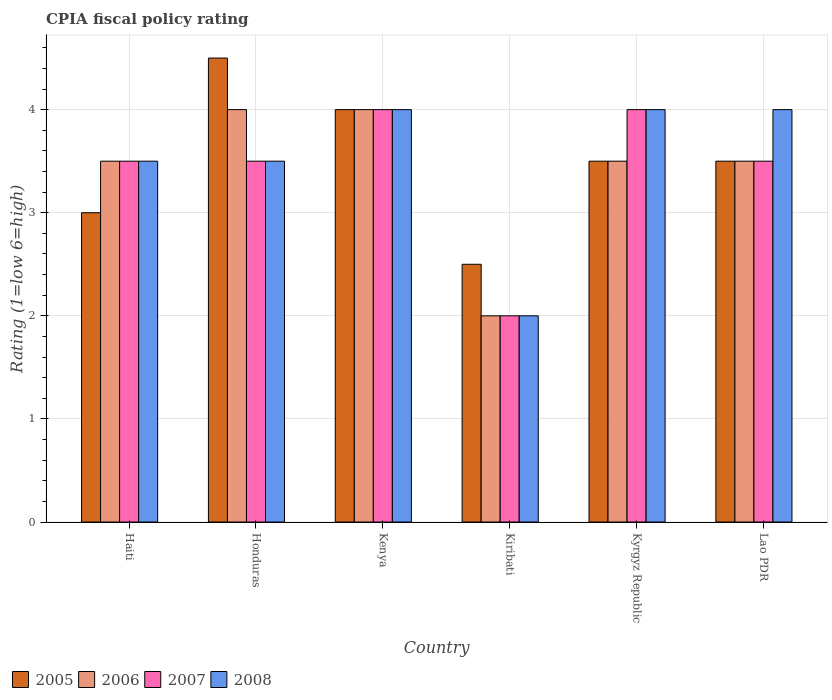Are the number of bars per tick equal to the number of legend labels?
Your answer should be very brief. Yes. How many bars are there on the 4th tick from the right?
Your answer should be very brief. 4. What is the label of the 3rd group of bars from the left?
Keep it short and to the point. Kenya. Across all countries, what is the maximum CPIA rating in 2005?
Make the answer very short. 4.5. In which country was the CPIA rating in 2007 maximum?
Give a very brief answer. Kenya. In which country was the CPIA rating in 2008 minimum?
Provide a short and direct response. Kiribati. What is the total CPIA rating in 2006 in the graph?
Give a very brief answer. 20.5. What is the ratio of the CPIA rating in 2006 in Kyrgyz Republic to that in Lao PDR?
Give a very brief answer. 1. Is the CPIA rating in 2006 in Haiti less than that in Kiribati?
Give a very brief answer. No. What is the difference between the highest and the second highest CPIA rating in 2005?
Ensure brevity in your answer.  -1. What is the difference between the highest and the lowest CPIA rating in 2008?
Give a very brief answer. 2. Is the sum of the CPIA rating in 2007 in Haiti and Kiribati greater than the maximum CPIA rating in 2008 across all countries?
Your answer should be very brief. Yes. Is it the case that in every country, the sum of the CPIA rating in 2007 and CPIA rating in 2005 is greater than the sum of CPIA rating in 2008 and CPIA rating in 2006?
Offer a terse response. No. Are all the bars in the graph horizontal?
Your response must be concise. No. How many countries are there in the graph?
Provide a succinct answer. 6. Does the graph contain any zero values?
Provide a short and direct response. No. What is the title of the graph?
Offer a very short reply. CPIA fiscal policy rating. Does "1978" appear as one of the legend labels in the graph?
Your answer should be very brief. No. What is the label or title of the X-axis?
Your answer should be very brief. Country. What is the label or title of the Y-axis?
Your answer should be compact. Rating (1=low 6=high). What is the Rating (1=low 6=high) in 2005 in Haiti?
Offer a terse response. 3. What is the Rating (1=low 6=high) in 2007 in Haiti?
Make the answer very short. 3.5. What is the Rating (1=low 6=high) of 2008 in Honduras?
Your answer should be very brief. 3.5. What is the Rating (1=low 6=high) in 2007 in Kenya?
Ensure brevity in your answer.  4. What is the Rating (1=low 6=high) of 2008 in Kenya?
Give a very brief answer. 4. What is the Rating (1=low 6=high) of 2005 in Kiribati?
Offer a very short reply. 2.5. What is the Rating (1=low 6=high) of 2006 in Kiribati?
Your response must be concise. 2. What is the Rating (1=low 6=high) in 2008 in Kiribati?
Give a very brief answer. 2. What is the Rating (1=low 6=high) of 2005 in Kyrgyz Republic?
Offer a terse response. 3.5. What is the Rating (1=low 6=high) in 2006 in Kyrgyz Republic?
Your answer should be very brief. 3.5. What is the Rating (1=low 6=high) in 2008 in Kyrgyz Republic?
Your answer should be compact. 4. What is the Rating (1=low 6=high) of 2005 in Lao PDR?
Your answer should be compact. 3.5. What is the Rating (1=low 6=high) of 2006 in Lao PDR?
Offer a terse response. 3.5. What is the Rating (1=low 6=high) of 2007 in Lao PDR?
Provide a succinct answer. 3.5. Across all countries, what is the maximum Rating (1=low 6=high) of 2005?
Your answer should be compact. 4.5. Across all countries, what is the maximum Rating (1=low 6=high) of 2008?
Your answer should be very brief. 4. Across all countries, what is the minimum Rating (1=low 6=high) in 2006?
Your answer should be compact. 2. Across all countries, what is the minimum Rating (1=low 6=high) of 2007?
Your answer should be very brief. 2. Across all countries, what is the minimum Rating (1=low 6=high) in 2008?
Keep it short and to the point. 2. What is the total Rating (1=low 6=high) of 2007 in the graph?
Your answer should be compact. 20.5. What is the total Rating (1=low 6=high) in 2008 in the graph?
Make the answer very short. 21. What is the difference between the Rating (1=low 6=high) of 2006 in Haiti and that in Honduras?
Your answer should be compact. -0.5. What is the difference between the Rating (1=low 6=high) of 2008 in Haiti and that in Kenya?
Ensure brevity in your answer.  -0.5. What is the difference between the Rating (1=low 6=high) of 2005 in Haiti and that in Kiribati?
Make the answer very short. 0.5. What is the difference between the Rating (1=low 6=high) in 2007 in Haiti and that in Kiribati?
Give a very brief answer. 1.5. What is the difference between the Rating (1=low 6=high) of 2007 in Haiti and that in Kyrgyz Republic?
Give a very brief answer. -0.5. What is the difference between the Rating (1=low 6=high) in 2008 in Haiti and that in Lao PDR?
Provide a succinct answer. -0.5. What is the difference between the Rating (1=low 6=high) in 2005 in Honduras and that in Kenya?
Ensure brevity in your answer.  0.5. What is the difference between the Rating (1=low 6=high) of 2006 in Honduras and that in Kenya?
Give a very brief answer. 0. What is the difference between the Rating (1=low 6=high) of 2007 in Honduras and that in Kiribati?
Ensure brevity in your answer.  1.5. What is the difference between the Rating (1=low 6=high) in 2008 in Honduras and that in Kiribati?
Offer a very short reply. 1.5. What is the difference between the Rating (1=low 6=high) in 2005 in Honduras and that in Kyrgyz Republic?
Provide a short and direct response. 1. What is the difference between the Rating (1=low 6=high) of 2007 in Honduras and that in Kyrgyz Republic?
Offer a terse response. -0.5. What is the difference between the Rating (1=low 6=high) in 2008 in Honduras and that in Lao PDR?
Provide a succinct answer. -0.5. What is the difference between the Rating (1=low 6=high) in 2005 in Kenya and that in Kyrgyz Republic?
Ensure brevity in your answer.  0.5. What is the difference between the Rating (1=low 6=high) of 2006 in Kenya and that in Kyrgyz Republic?
Your response must be concise. 0.5. What is the difference between the Rating (1=low 6=high) of 2006 in Kenya and that in Lao PDR?
Provide a succinct answer. 0.5. What is the difference between the Rating (1=low 6=high) in 2007 in Kenya and that in Lao PDR?
Ensure brevity in your answer.  0.5. What is the difference between the Rating (1=low 6=high) of 2008 in Kenya and that in Lao PDR?
Your answer should be compact. 0. What is the difference between the Rating (1=low 6=high) in 2006 in Kiribati and that in Kyrgyz Republic?
Offer a very short reply. -1.5. What is the difference between the Rating (1=low 6=high) in 2006 in Kiribati and that in Lao PDR?
Provide a succinct answer. -1.5. What is the difference between the Rating (1=low 6=high) in 2008 in Kiribati and that in Lao PDR?
Ensure brevity in your answer.  -2. What is the difference between the Rating (1=low 6=high) of 2005 in Kyrgyz Republic and that in Lao PDR?
Offer a very short reply. 0. What is the difference between the Rating (1=low 6=high) of 2006 in Kyrgyz Republic and that in Lao PDR?
Provide a short and direct response. 0. What is the difference between the Rating (1=low 6=high) in 2005 in Haiti and the Rating (1=low 6=high) in 2008 in Honduras?
Ensure brevity in your answer.  -0.5. What is the difference between the Rating (1=low 6=high) of 2005 in Haiti and the Rating (1=low 6=high) of 2007 in Kenya?
Keep it short and to the point. -1. What is the difference between the Rating (1=low 6=high) of 2006 in Haiti and the Rating (1=low 6=high) of 2008 in Kenya?
Provide a short and direct response. -0.5. What is the difference between the Rating (1=low 6=high) of 2007 in Haiti and the Rating (1=low 6=high) of 2008 in Kiribati?
Provide a short and direct response. 1.5. What is the difference between the Rating (1=low 6=high) of 2005 in Haiti and the Rating (1=low 6=high) of 2006 in Kyrgyz Republic?
Your answer should be very brief. -0.5. What is the difference between the Rating (1=low 6=high) of 2005 in Haiti and the Rating (1=low 6=high) of 2007 in Kyrgyz Republic?
Provide a short and direct response. -1. What is the difference between the Rating (1=low 6=high) in 2006 in Haiti and the Rating (1=low 6=high) in 2007 in Kyrgyz Republic?
Make the answer very short. -0.5. What is the difference between the Rating (1=low 6=high) of 2007 in Haiti and the Rating (1=low 6=high) of 2008 in Kyrgyz Republic?
Provide a short and direct response. -0.5. What is the difference between the Rating (1=low 6=high) of 2005 in Haiti and the Rating (1=low 6=high) of 2007 in Lao PDR?
Keep it short and to the point. -0.5. What is the difference between the Rating (1=low 6=high) of 2005 in Haiti and the Rating (1=low 6=high) of 2008 in Lao PDR?
Provide a short and direct response. -1. What is the difference between the Rating (1=low 6=high) in 2005 in Honduras and the Rating (1=low 6=high) in 2006 in Kenya?
Provide a short and direct response. 0.5. What is the difference between the Rating (1=low 6=high) of 2005 in Honduras and the Rating (1=low 6=high) of 2007 in Kenya?
Provide a succinct answer. 0.5. What is the difference between the Rating (1=low 6=high) in 2005 in Honduras and the Rating (1=low 6=high) in 2008 in Kenya?
Your response must be concise. 0.5. What is the difference between the Rating (1=low 6=high) of 2007 in Honduras and the Rating (1=low 6=high) of 2008 in Kenya?
Provide a succinct answer. -0.5. What is the difference between the Rating (1=low 6=high) of 2005 in Honduras and the Rating (1=low 6=high) of 2006 in Kiribati?
Your answer should be compact. 2.5. What is the difference between the Rating (1=low 6=high) in 2005 in Honduras and the Rating (1=low 6=high) in 2007 in Kiribati?
Offer a terse response. 2.5. What is the difference between the Rating (1=low 6=high) of 2005 in Honduras and the Rating (1=low 6=high) of 2008 in Kiribati?
Provide a short and direct response. 2.5. What is the difference between the Rating (1=low 6=high) of 2006 in Honduras and the Rating (1=low 6=high) of 2007 in Kiribati?
Your response must be concise. 2. What is the difference between the Rating (1=low 6=high) of 2007 in Honduras and the Rating (1=low 6=high) of 2008 in Kiribati?
Provide a succinct answer. 1.5. What is the difference between the Rating (1=low 6=high) in 2005 in Honduras and the Rating (1=low 6=high) in 2006 in Kyrgyz Republic?
Provide a succinct answer. 1. What is the difference between the Rating (1=low 6=high) of 2005 in Honduras and the Rating (1=low 6=high) of 2007 in Kyrgyz Republic?
Your response must be concise. 0.5. What is the difference between the Rating (1=low 6=high) of 2006 in Honduras and the Rating (1=low 6=high) of 2007 in Kyrgyz Republic?
Give a very brief answer. 0. What is the difference between the Rating (1=low 6=high) of 2005 in Honduras and the Rating (1=low 6=high) of 2008 in Lao PDR?
Provide a succinct answer. 0.5. What is the difference between the Rating (1=low 6=high) of 2007 in Honduras and the Rating (1=low 6=high) of 2008 in Lao PDR?
Keep it short and to the point. -0.5. What is the difference between the Rating (1=low 6=high) in 2005 in Kenya and the Rating (1=low 6=high) in 2007 in Kiribati?
Keep it short and to the point. 2. What is the difference between the Rating (1=low 6=high) in 2005 in Kenya and the Rating (1=low 6=high) in 2006 in Kyrgyz Republic?
Ensure brevity in your answer.  0.5. What is the difference between the Rating (1=low 6=high) of 2005 in Kenya and the Rating (1=low 6=high) of 2008 in Kyrgyz Republic?
Offer a terse response. 0. What is the difference between the Rating (1=low 6=high) in 2006 in Kenya and the Rating (1=low 6=high) in 2007 in Kyrgyz Republic?
Make the answer very short. 0. What is the difference between the Rating (1=low 6=high) of 2006 in Kenya and the Rating (1=low 6=high) of 2008 in Kyrgyz Republic?
Give a very brief answer. 0. What is the difference between the Rating (1=low 6=high) in 2005 in Kenya and the Rating (1=low 6=high) in 2006 in Lao PDR?
Ensure brevity in your answer.  0.5. What is the difference between the Rating (1=low 6=high) of 2006 in Kenya and the Rating (1=low 6=high) of 2008 in Lao PDR?
Your answer should be compact. 0. What is the difference between the Rating (1=low 6=high) of 2005 in Kiribati and the Rating (1=low 6=high) of 2006 in Kyrgyz Republic?
Your answer should be compact. -1. What is the difference between the Rating (1=low 6=high) of 2005 in Kiribati and the Rating (1=low 6=high) of 2008 in Kyrgyz Republic?
Offer a terse response. -1.5. What is the difference between the Rating (1=low 6=high) in 2006 in Kiribati and the Rating (1=low 6=high) in 2007 in Kyrgyz Republic?
Make the answer very short. -2. What is the difference between the Rating (1=low 6=high) of 2006 in Kiribati and the Rating (1=low 6=high) of 2008 in Kyrgyz Republic?
Ensure brevity in your answer.  -2. What is the difference between the Rating (1=low 6=high) of 2007 in Kiribati and the Rating (1=low 6=high) of 2008 in Kyrgyz Republic?
Your answer should be very brief. -2. What is the difference between the Rating (1=low 6=high) of 2005 in Kiribati and the Rating (1=low 6=high) of 2007 in Lao PDR?
Provide a short and direct response. -1. What is the difference between the Rating (1=low 6=high) in 2006 in Kiribati and the Rating (1=low 6=high) in 2007 in Lao PDR?
Make the answer very short. -1.5. What is the difference between the Rating (1=low 6=high) of 2006 in Kiribati and the Rating (1=low 6=high) of 2008 in Lao PDR?
Keep it short and to the point. -2. What is the difference between the Rating (1=low 6=high) in 2007 in Kiribati and the Rating (1=low 6=high) in 2008 in Lao PDR?
Give a very brief answer. -2. What is the average Rating (1=low 6=high) in 2005 per country?
Provide a succinct answer. 3.5. What is the average Rating (1=low 6=high) in 2006 per country?
Your answer should be compact. 3.42. What is the average Rating (1=low 6=high) of 2007 per country?
Give a very brief answer. 3.42. What is the difference between the Rating (1=low 6=high) in 2006 and Rating (1=low 6=high) in 2007 in Haiti?
Provide a short and direct response. 0. What is the difference between the Rating (1=low 6=high) in 2007 and Rating (1=low 6=high) in 2008 in Haiti?
Your answer should be very brief. 0. What is the difference between the Rating (1=low 6=high) of 2005 and Rating (1=low 6=high) of 2007 in Kenya?
Your answer should be compact. 0. What is the difference between the Rating (1=low 6=high) of 2005 and Rating (1=low 6=high) of 2008 in Kenya?
Offer a very short reply. 0. What is the difference between the Rating (1=low 6=high) of 2005 and Rating (1=low 6=high) of 2006 in Kiribati?
Your answer should be very brief. 0.5. What is the difference between the Rating (1=low 6=high) in 2005 and Rating (1=low 6=high) in 2007 in Kiribati?
Your answer should be very brief. 0.5. What is the difference between the Rating (1=low 6=high) in 2006 and Rating (1=low 6=high) in 2008 in Kiribati?
Ensure brevity in your answer.  0. What is the difference between the Rating (1=low 6=high) of 2007 and Rating (1=low 6=high) of 2008 in Kiribati?
Make the answer very short. 0. What is the difference between the Rating (1=low 6=high) in 2005 and Rating (1=low 6=high) in 2006 in Kyrgyz Republic?
Provide a short and direct response. 0. What is the difference between the Rating (1=low 6=high) of 2006 and Rating (1=low 6=high) of 2007 in Kyrgyz Republic?
Your response must be concise. -0.5. What is the difference between the Rating (1=low 6=high) of 2006 and Rating (1=low 6=high) of 2008 in Kyrgyz Republic?
Offer a terse response. -0.5. What is the difference between the Rating (1=low 6=high) of 2005 and Rating (1=low 6=high) of 2006 in Lao PDR?
Make the answer very short. 0. What is the difference between the Rating (1=low 6=high) in 2005 and Rating (1=low 6=high) in 2007 in Lao PDR?
Offer a very short reply. 0. What is the difference between the Rating (1=low 6=high) in 2005 and Rating (1=low 6=high) in 2008 in Lao PDR?
Provide a short and direct response. -0.5. What is the difference between the Rating (1=low 6=high) of 2006 and Rating (1=low 6=high) of 2008 in Lao PDR?
Your response must be concise. -0.5. What is the ratio of the Rating (1=low 6=high) in 2006 in Haiti to that in Honduras?
Keep it short and to the point. 0.88. What is the ratio of the Rating (1=low 6=high) in 2007 in Haiti to that in Honduras?
Your response must be concise. 1. What is the ratio of the Rating (1=low 6=high) of 2008 in Haiti to that in Honduras?
Offer a terse response. 1. What is the ratio of the Rating (1=low 6=high) of 2005 in Haiti to that in Kiribati?
Your response must be concise. 1.2. What is the ratio of the Rating (1=low 6=high) in 2008 in Haiti to that in Kiribati?
Your answer should be compact. 1.75. What is the ratio of the Rating (1=low 6=high) in 2006 in Haiti to that in Lao PDR?
Give a very brief answer. 1. What is the ratio of the Rating (1=low 6=high) in 2008 in Haiti to that in Lao PDR?
Your response must be concise. 0.88. What is the ratio of the Rating (1=low 6=high) of 2005 in Honduras to that in Kenya?
Provide a short and direct response. 1.12. What is the ratio of the Rating (1=low 6=high) in 2008 in Honduras to that in Kenya?
Make the answer very short. 0.88. What is the ratio of the Rating (1=low 6=high) of 2007 in Honduras to that in Kiribati?
Make the answer very short. 1.75. What is the ratio of the Rating (1=low 6=high) of 2007 in Honduras to that in Kyrgyz Republic?
Give a very brief answer. 0.88. What is the ratio of the Rating (1=low 6=high) in 2008 in Honduras to that in Lao PDR?
Keep it short and to the point. 0.88. What is the ratio of the Rating (1=low 6=high) of 2006 in Kenya to that in Kiribati?
Give a very brief answer. 2. What is the ratio of the Rating (1=low 6=high) of 2007 in Kenya to that in Kiribati?
Ensure brevity in your answer.  2. What is the ratio of the Rating (1=low 6=high) of 2008 in Kenya to that in Kiribati?
Offer a terse response. 2. What is the ratio of the Rating (1=low 6=high) in 2005 in Kenya to that in Kyrgyz Republic?
Make the answer very short. 1.14. What is the ratio of the Rating (1=low 6=high) of 2006 in Kenya to that in Kyrgyz Republic?
Offer a very short reply. 1.14. What is the ratio of the Rating (1=low 6=high) in 2007 in Kenya to that in Kyrgyz Republic?
Make the answer very short. 1. What is the ratio of the Rating (1=low 6=high) of 2008 in Kenya to that in Kyrgyz Republic?
Your answer should be compact. 1. What is the ratio of the Rating (1=low 6=high) of 2005 in Kenya to that in Lao PDR?
Provide a succinct answer. 1.14. What is the ratio of the Rating (1=low 6=high) of 2007 in Kenya to that in Lao PDR?
Your answer should be very brief. 1.14. What is the ratio of the Rating (1=low 6=high) in 2005 in Kiribati to that in Kyrgyz Republic?
Make the answer very short. 0.71. What is the ratio of the Rating (1=low 6=high) in 2007 in Kiribati to that in Kyrgyz Republic?
Ensure brevity in your answer.  0.5. What is the ratio of the Rating (1=low 6=high) of 2008 in Kiribati to that in Kyrgyz Republic?
Offer a terse response. 0.5. What is the ratio of the Rating (1=low 6=high) of 2006 in Kiribati to that in Lao PDR?
Provide a short and direct response. 0.57. What is the ratio of the Rating (1=low 6=high) in 2007 in Kiribati to that in Lao PDR?
Offer a terse response. 0.57. What is the ratio of the Rating (1=low 6=high) of 2008 in Kiribati to that in Lao PDR?
Make the answer very short. 0.5. What is the ratio of the Rating (1=low 6=high) of 2005 in Kyrgyz Republic to that in Lao PDR?
Keep it short and to the point. 1. What is the ratio of the Rating (1=low 6=high) in 2006 in Kyrgyz Republic to that in Lao PDR?
Keep it short and to the point. 1. What is the ratio of the Rating (1=low 6=high) in 2007 in Kyrgyz Republic to that in Lao PDR?
Provide a short and direct response. 1.14. What is the difference between the highest and the second highest Rating (1=low 6=high) of 2005?
Give a very brief answer. 0.5. What is the difference between the highest and the second highest Rating (1=low 6=high) of 2007?
Keep it short and to the point. 0. What is the difference between the highest and the second highest Rating (1=low 6=high) of 2008?
Provide a short and direct response. 0. What is the difference between the highest and the lowest Rating (1=low 6=high) in 2006?
Keep it short and to the point. 2. What is the difference between the highest and the lowest Rating (1=low 6=high) in 2007?
Make the answer very short. 2. 